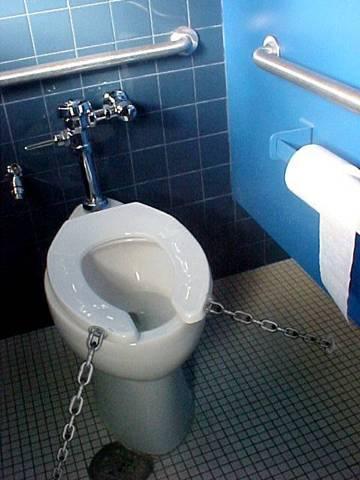What is on the toilet?
Write a very short answer. Chains. Are those chains on the toilet?
Short answer required. Yes. What color is the tile?
Quick response, please. Blue. 